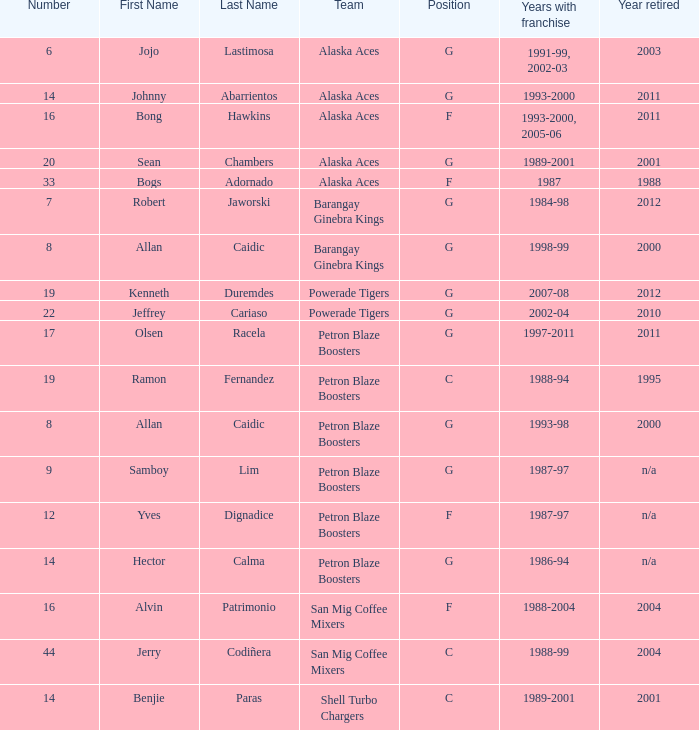Which team is number 14 and had a franchise in 1993-2000? Alaska Aces. 